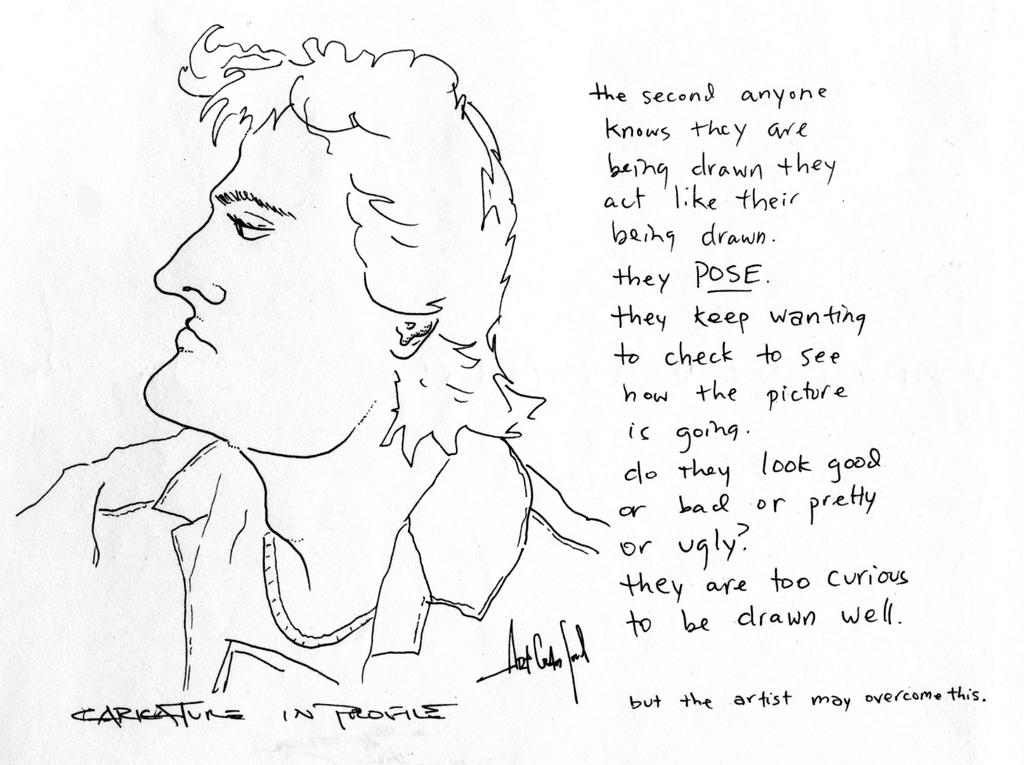What is depicted in the image? There is a drawing of a person in the image. What else can be seen in the image besides the drawing? There is text written on the right side of the image. What type of reaction can be seen from the person's nose in the image? There is no reaction visible from the person's nose in the image, as it is a drawing and not a real person. 